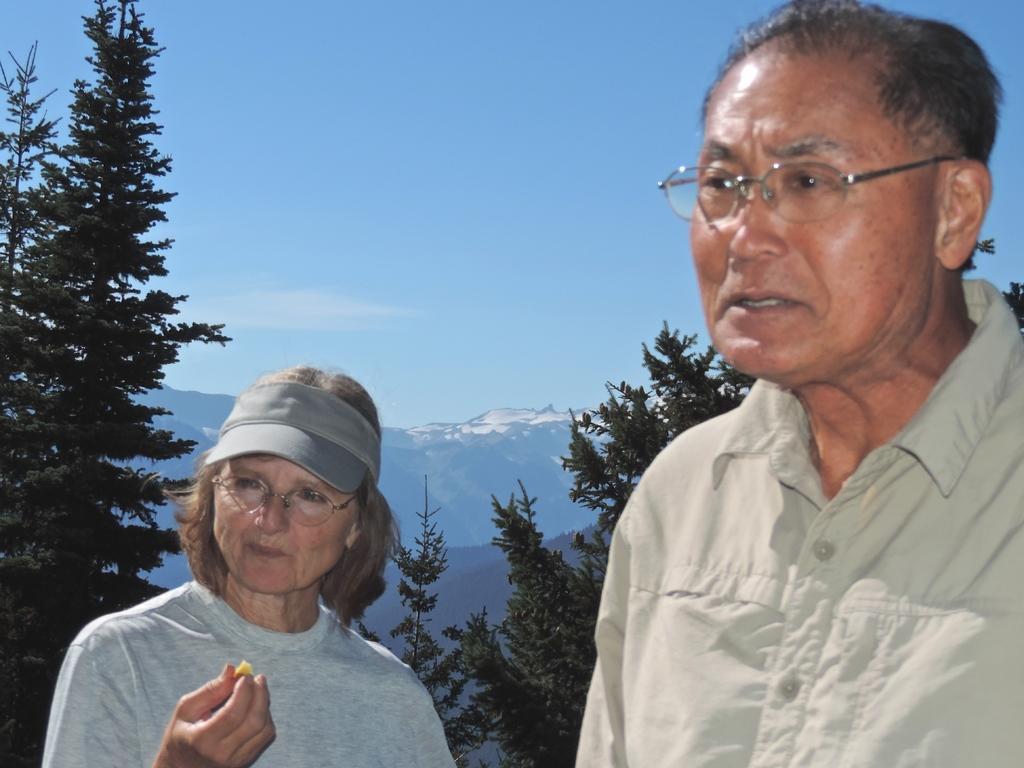In one or two sentences, can you explain what this image depicts? In this image there are two persons standing, one of them is holding something in her hand. In the background there are trees, mountains and a sky. 